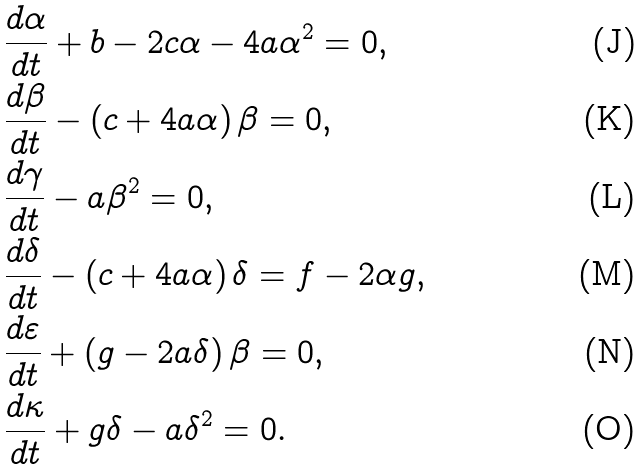<formula> <loc_0><loc_0><loc_500><loc_500>& \frac { d \alpha } { d t } + b - 2 c \alpha - 4 a \alpha ^ { 2 } = 0 , \\ & \frac { d \beta } { d t } - \left ( c + 4 a \alpha \right ) \beta = 0 , \\ & \frac { d \gamma } { d t } - a \beta ^ { 2 } = 0 , \\ & \frac { d \delta } { d t } - \left ( c + 4 a \alpha \right ) \delta = f - 2 \alpha g , \\ & \frac { d \varepsilon } { d t } + \left ( g - 2 a \delta \right ) \beta = 0 , \\ & \frac { d \kappa } { d t } + g \delta - a \delta ^ { 2 } = 0 .</formula> 